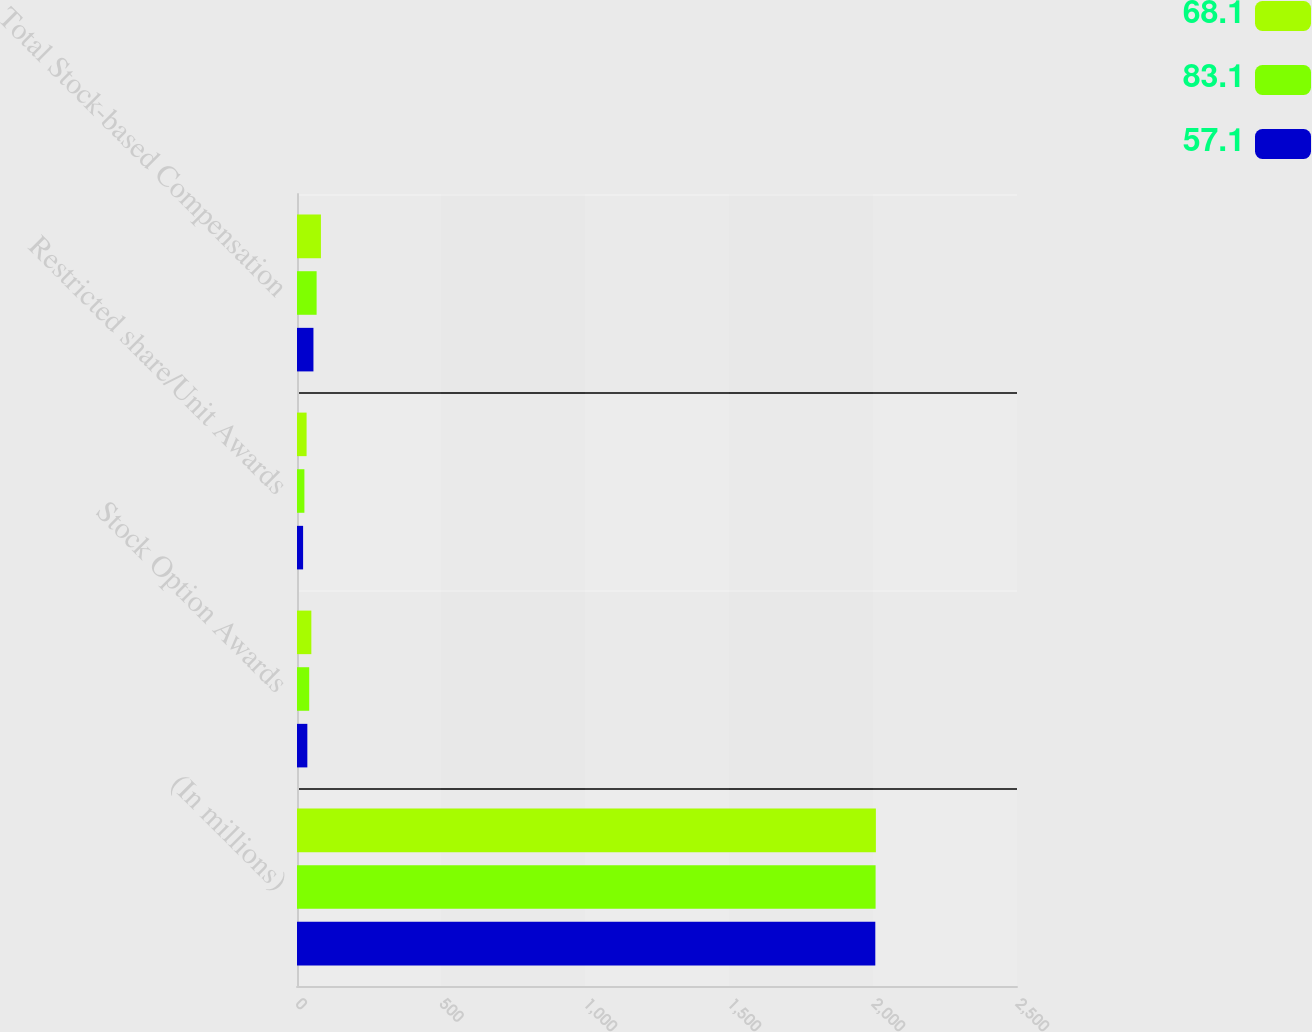<chart> <loc_0><loc_0><loc_500><loc_500><stacked_bar_chart><ecel><fcel>(In millions)<fcel>Stock Option Awards<fcel>Restricted share/Unit Awards<fcel>Total Stock-based Compensation<nl><fcel>68.1<fcel>2010<fcel>49.8<fcel>33.3<fcel>83.1<nl><fcel>83.1<fcel>2009<fcel>42.4<fcel>25.7<fcel>68.1<nl><fcel>57.1<fcel>2008<fcel>35.9<fcel>21.2<fcel>57.1<nl></chart> 